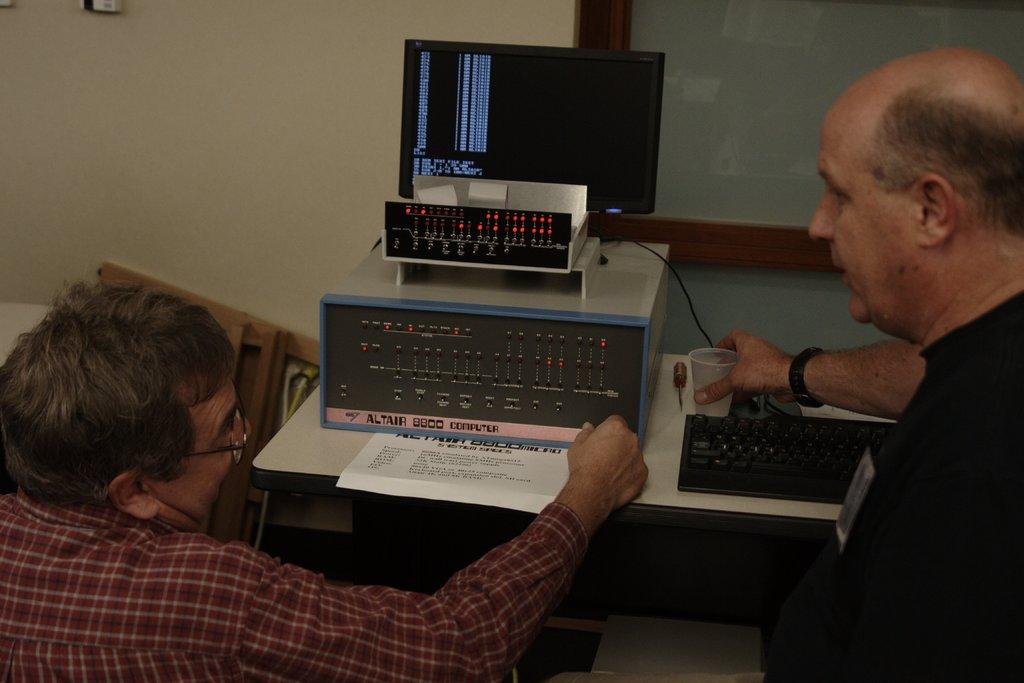Provide a one-sentence caption for the provided image. Two men are looking and discussing the data from Altair 8800 computer. 